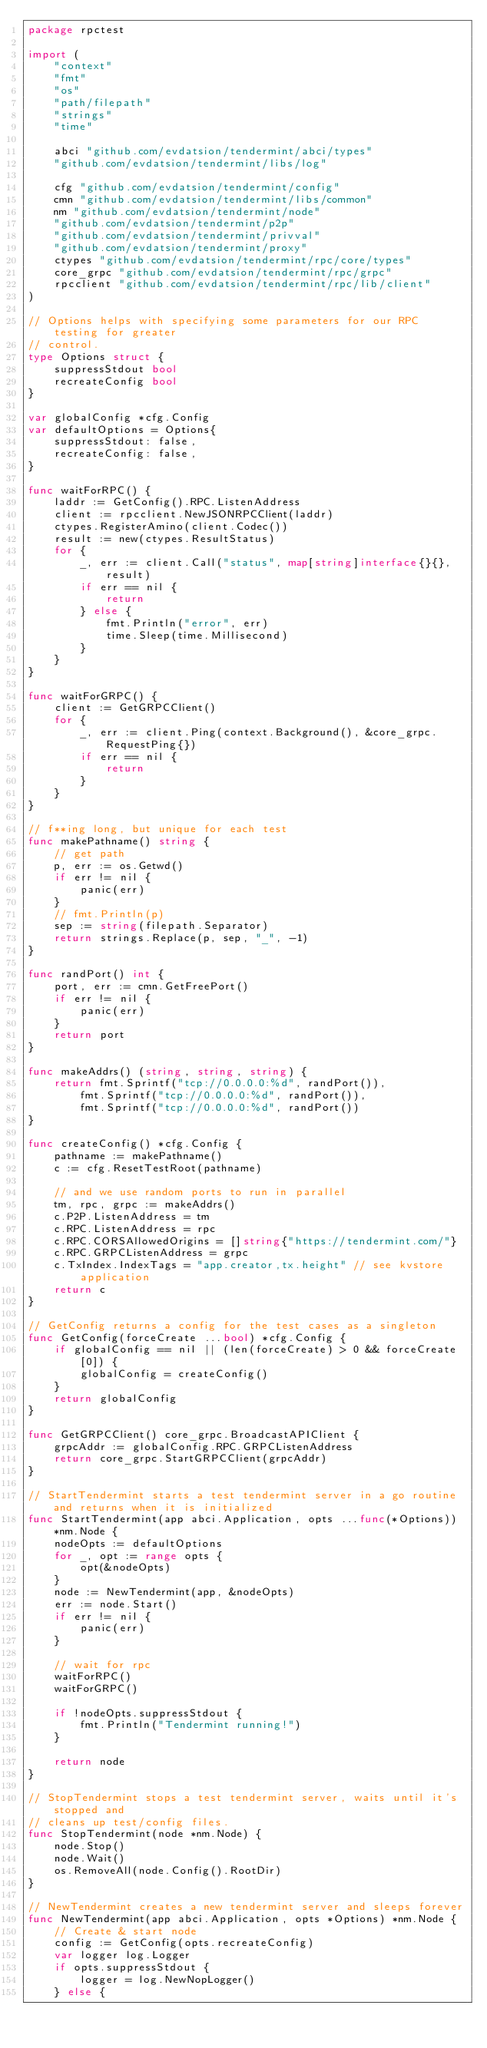<code> <loc_0><loc_0><loc_500><loc_500><_Go_>package rpctest

import (
	"context"
	"fmt"
	"os"
	"path/filepath"
	"strings"
	"time"

	abci "github.com/evdatsion/tendermint/abci/types"
	"github.com/evdatsion/tendermint/libs/log"

	cfg "github.com/evdatsion/tendermint/config"
	cmn "github.com/evdatsion/tendermint/libs/common"
	nm "github.com/evdatsion/tendermint/node"
	"github.com/evdatsion/tendermint/p2p"
	"github.com/evdatsion/tendermint/privval"
	"github.com/evdatsion/tendermint/proxy"
	ctypes "github.com/evdatsion/tendermint/rpc/core/types"
	core_grpc "github.com/evdatsion/tendermint/rpc/grpc"
	rpcclient "github.com/evdatsion/tendermint/rpc/lib/client"
)

// Options helps with specifying some parameters for our RPC testing for greater
// control.
type Options struct {
	suppressStdout bool
	recreateConfig bool
}

var globalConfig *cfg.Config
var defaultOptions = Options{
	suppressStdout: false,
	recreateConfig: false,
}

func waitForRPC() {
	laddr := GetConfig().RPC.ListenAddress
	client := rpcclient.NewJSONRPCClient(laddr)
	ctypes.RegisterAmino(client.Codec())
	result := new(ctypes.ResultStatus)
	for {
		_, err := client.Call("status", map[string]interface{}{}, result)
		if err == nil {
			return
		} else {
			fmt.Println("error", err)
			time.Sleep(time.Millisecond)
		}
	}
}

func waitForGRPC() {
	client := GetGRPCClient()
	for {
		_, err := client.Ping(context.Background(), &core_grpc.RequestPing{})
		if err == nil {
			return
		}
	}
}

// f**ing long, but unique for each test
func makePathname() string {
	// get path
	p, err := os.Getwd()
	if err != nil {
		panic(err)
	}
	// fmt.Println(p)
	sep := string(filepath.Separator)
	return strings.Replace(p, sep, "_", -1)
}

func randPort() int {
	port, err := cmn.GetFreePort()
	if err != nil {
		panic(err)
	}
	return port
}

func makeAddrs() (string, string, string) {
	return fmt.Sprintf("tcp://0.0.0.0:%d", randPort()),
		fmt.Sprintf("tcp://0.0.0.0:%d", randPort()),
		fmt.Sprintf("tcp://0.0.0.0:%d", randPort())
}

func createConfig() *cfg.Config {
	pathname := makePathname()
	c := cfg.ResetTestRoot(pathname)

	// and we use random ports to run in parallel
	tm, rpc, grpc := makeAddrs()
	c.P2P.ListenAddress = tm
	c.RPC.ListenAddress = rpc
	c.RPC.CORSAllowedOrigins = []string{"https://tendermint.com/"}
	c.RPC.GRPCListenAddress = grpc
	c.TxIndex.IndexTags = "app.creator,tx.height" // see kvstore application
	return c
}

// GetConfig returns a config for the test cases as a singleton
func GetConfig(forceCreate ...bool) *cfg.Config {
	if globalConfig == nil || (len(forceCreate) > 0 && forceCreate[0]) {
		globalConfig = createConfig()
	}
	return globalConfig
}

func GetGRPCClient() core_grpc.BroadcastAPIClient {
	grpcAddr := globalConfig.RPC.GRPCListenAddress
	return core_grpc.StartGRPCClient(grpcAddr)
}

// StartTendermint starts a test tendermint server in a go routine and returns when it is initialized
func StartTendermint(app abci.Application, opts ...func(*Options)) *nm.Node {
	nodeOpts := defaultOptions
	for _, opt := range opts {
		opt(&nodeOpts)
	}
	node := NewTendermint(app, &nodeOpts)
	err := node.Start()
	if err != nil {
		panic(err)
	}

	// wait for rpc
	waitForRPC()
	waitForGRPC()

	if !nodeOpts.suppressStdout {
		fmt.Println("Tendermint running!")
	}

	return node
}

// StopTendermint stops a test tendermint server, waits until it's stopped and
// cleans up test/config files.
func StopTendermint(node *nm.Node) {
	node.Stop()
	node.Wait()
	os.RemoveAll(node.Config().RootDir)
}

// NewTendermint creates a new tendermint server and sleeps forever
func NewTendermint(app abci.Application, opts *Options) *nm.Node {
	// Create & start node
	config := GetConfig(opts.recreateConfig)
	var logger log.Logger
	if opts.suppressStdout {
		logger = log.NewNopLogger()
	} else {</code> 